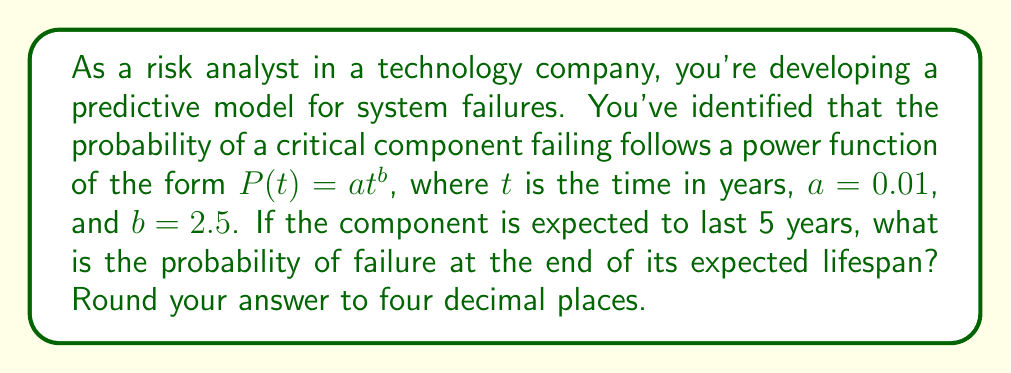What is the answer to this math problem? To solve this problem, we need to use the given power function and substitute the known values:

1. The power function is given as:
   $P(t) = at^b$

2. We know that:
   $a = 0.01$
   $b = 2.5$
   $t = 5$ years (expected lifespan)

3. Let's substitute these values into the equation:
   $P(5) = 0.01 \cdot 5^{2.5}$

4. Now, let's calculate step by step:
   $5^{2.5} = 5^2 \cdot 5^{0.5} = 25 \cdot \sqrt{5} \approx 55.9017$

5. Multiply this by 0.01:
   $P(5) = 0.01 \cdot 55.9017 = 0.559017$

6. Rounding to four decimal places:
   $P(5) \approx 0.5590$

This result indicates that there's approximately a 55.90% chance of the component failing by the end of its expected 5-year lifespan.
Answer: 0.5590 